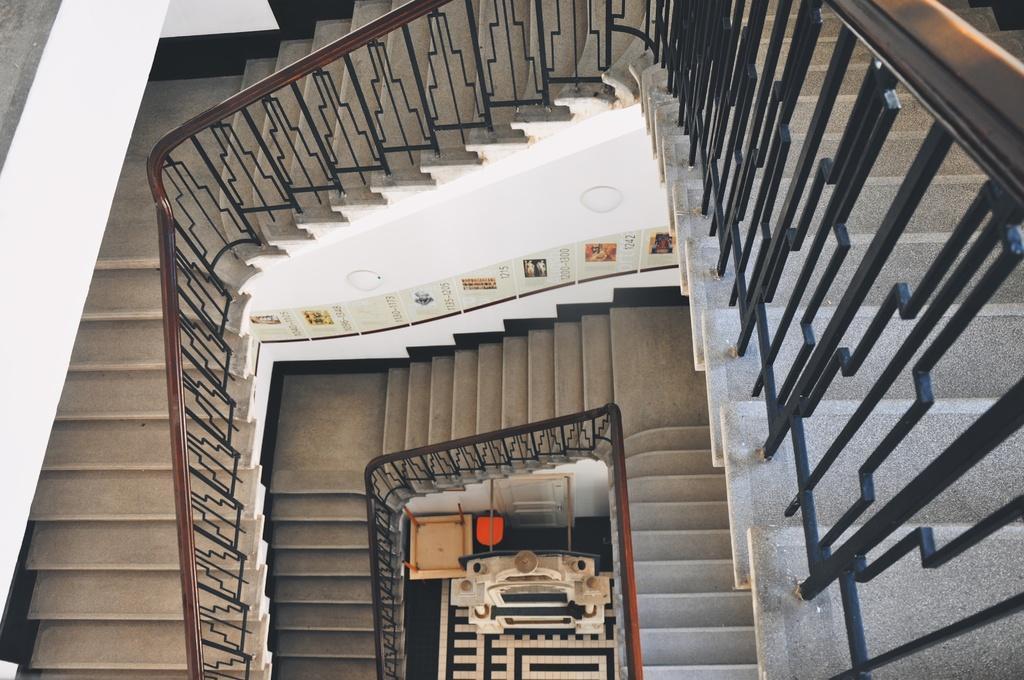Please provide a concise description of this image. This picture is inside view of a room. In the background of the image we can stairs are there. At the bottom of the image we can see some tables are present. 